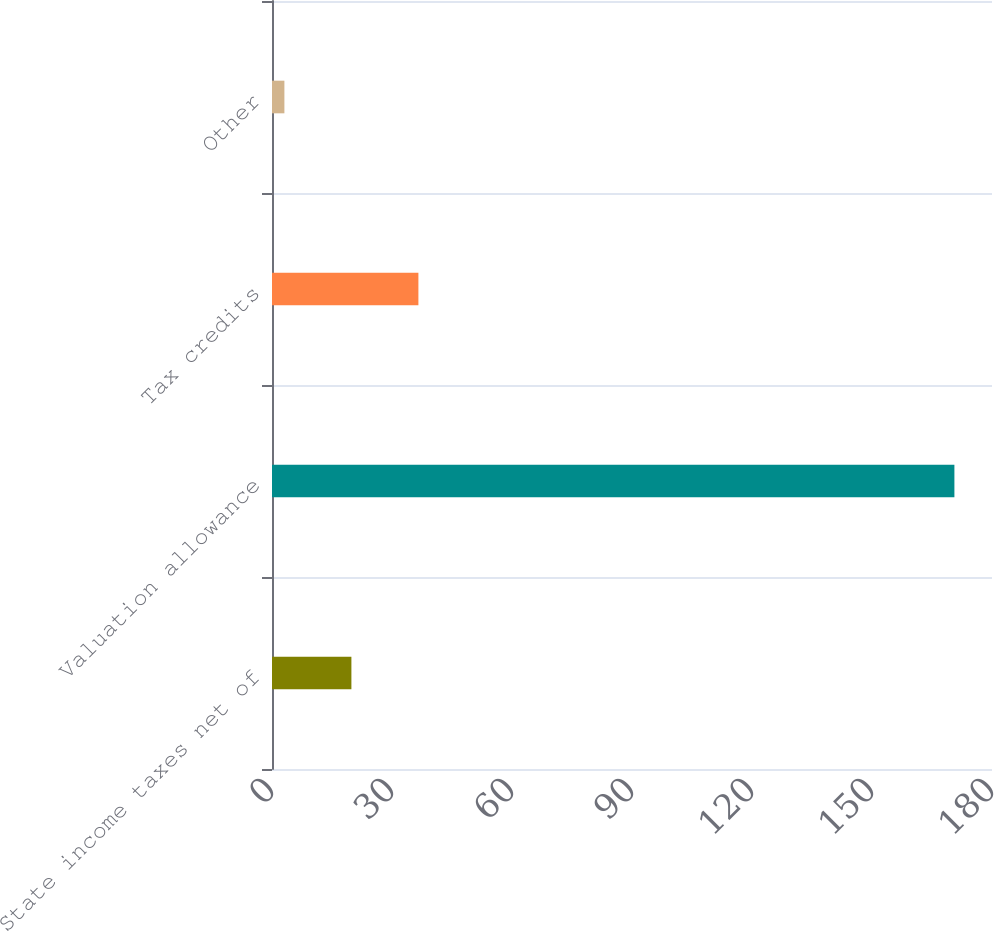Convert chart. <chart><loc_0><loc_0><loc_500><loc_500><bar_chart><fcel>State income taxes net of<fcel>Valuation allowance<fcel>Tax credits<fcel>Other<nl><fcel>19.85<fcel>170.6<fcel>36.6<fcel>3.1<nl></chart> 